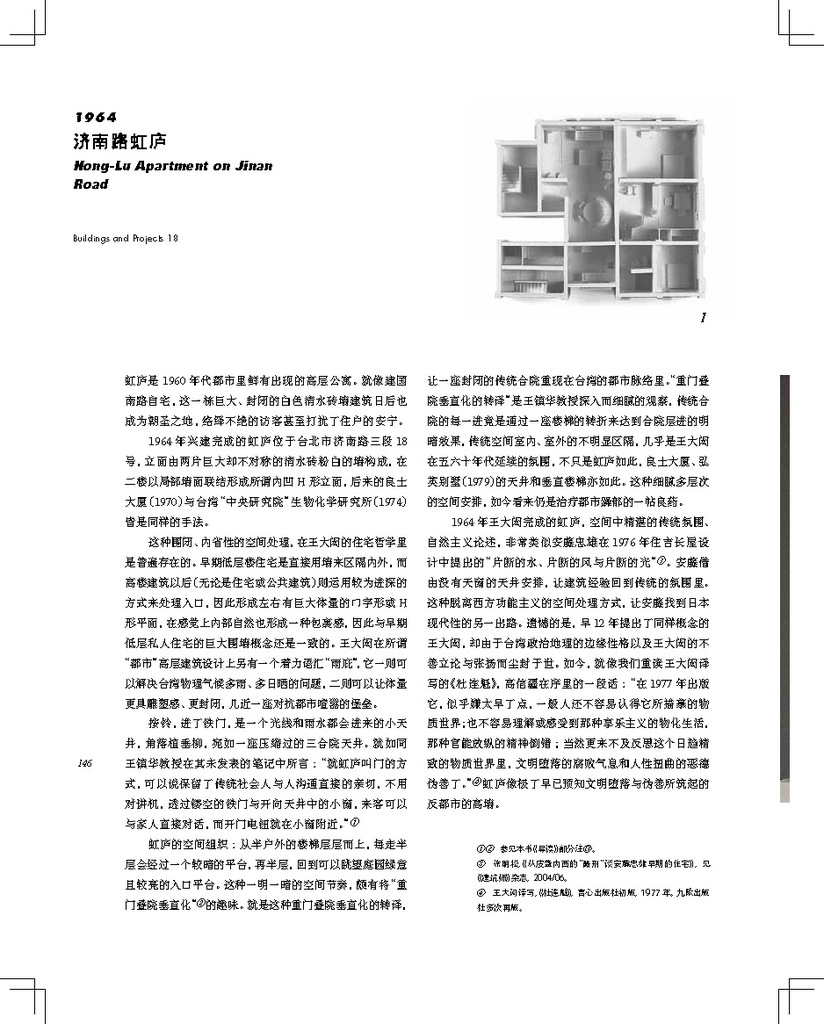Provide a one-sentence caption for the provided image. The image displays a detailed architectural floor plan of the Hong Lu apartment, revealing the intricate layout and room design of the 1964 building project situated on Jinan Road. 